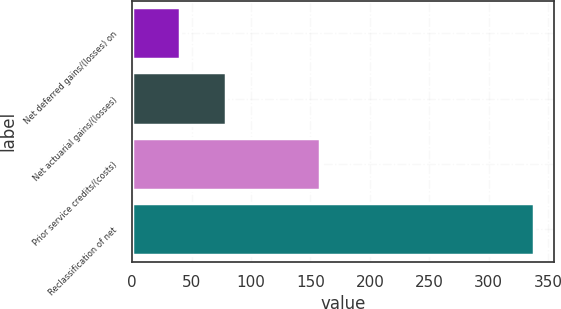<chart> <loc_0><loc_0><loc_500><loc_500><bar_chart><fcel>Net deferred gains/(losses) on<fcel>Net actuarial gains/(losses)<fcel>Prior service credits/(costs)<fcel>Reclassification of net<nl><fcel>40<fcel>78.6<fcel>158<fcel>338<nl></chart> 